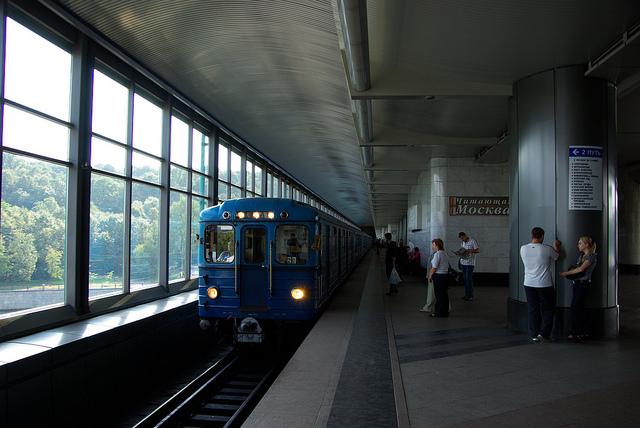Why are the people in the photo?
Concise answer only. Waiting for train. What color is the train?
Concise answer only. Blue. What type of vehicle is that?
Write a very short answer. Train. Is the roof glass?
Be succinct. No. What color are the leaves?
Give a very brief answer. Green. Is it daytime?
Write a very short answer. Yes. Is the train shiny?
Keep it brief. No. What is the man on the right doing while walking?
Keep it brief. Reading. What type of transportation is this?
Concise answer only. Train. 